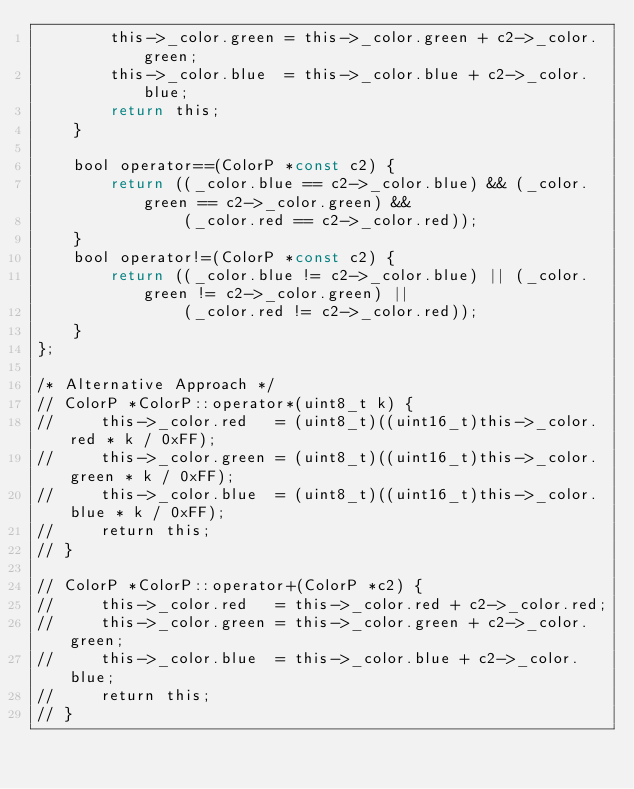Convert code to text. <code><loc_0><loc_0><loc_500><loc_500><_C_>        this->_color.green = this->_color.green + c2->_color.green;
        this->_color.blue  = this->_color.blue + c2->_color.blue;
        return this;
    }

    bool operator==(ColorP *const c2) {
        return ((_color.blue == c2->_color.blue) && (_color.green == c2->_color.green) &&
                (_color.red == c2->_color.red));
    }
    bool operator!=(ColorP *const c2) {
        return ((_color.blue != c2->_color.blue) || (_color.green != c2->_color.green) ||
                (_color.red != c2->_color.red));
    }
};

/* Alternative Approach */
// ColorP *ColorP::operator*(uint8_t k) {
//     this->_color.red   = (uint8_t)((uint16_t)this->_color.red * k / 0xFF);
//     this->_color.green = (uint8_t)((uint16_t)this->_color.green * k / 0xFF);
//     this->_color.blue  = (uint8_t)((uint16_t)this->_color.blue * k / 0xFF);
//     return this;
// }

// ColorP *ColorP::operator+(ColorP *c2) {
//     this->_color.red   = this->_color.red + c2->_color.red;
//     this->_color.green = this->_color.green + c2->_color.green;
//     this->_color.blue  = this->_color.blue + c2->_color.blue;
//     return this;
// }</code> 